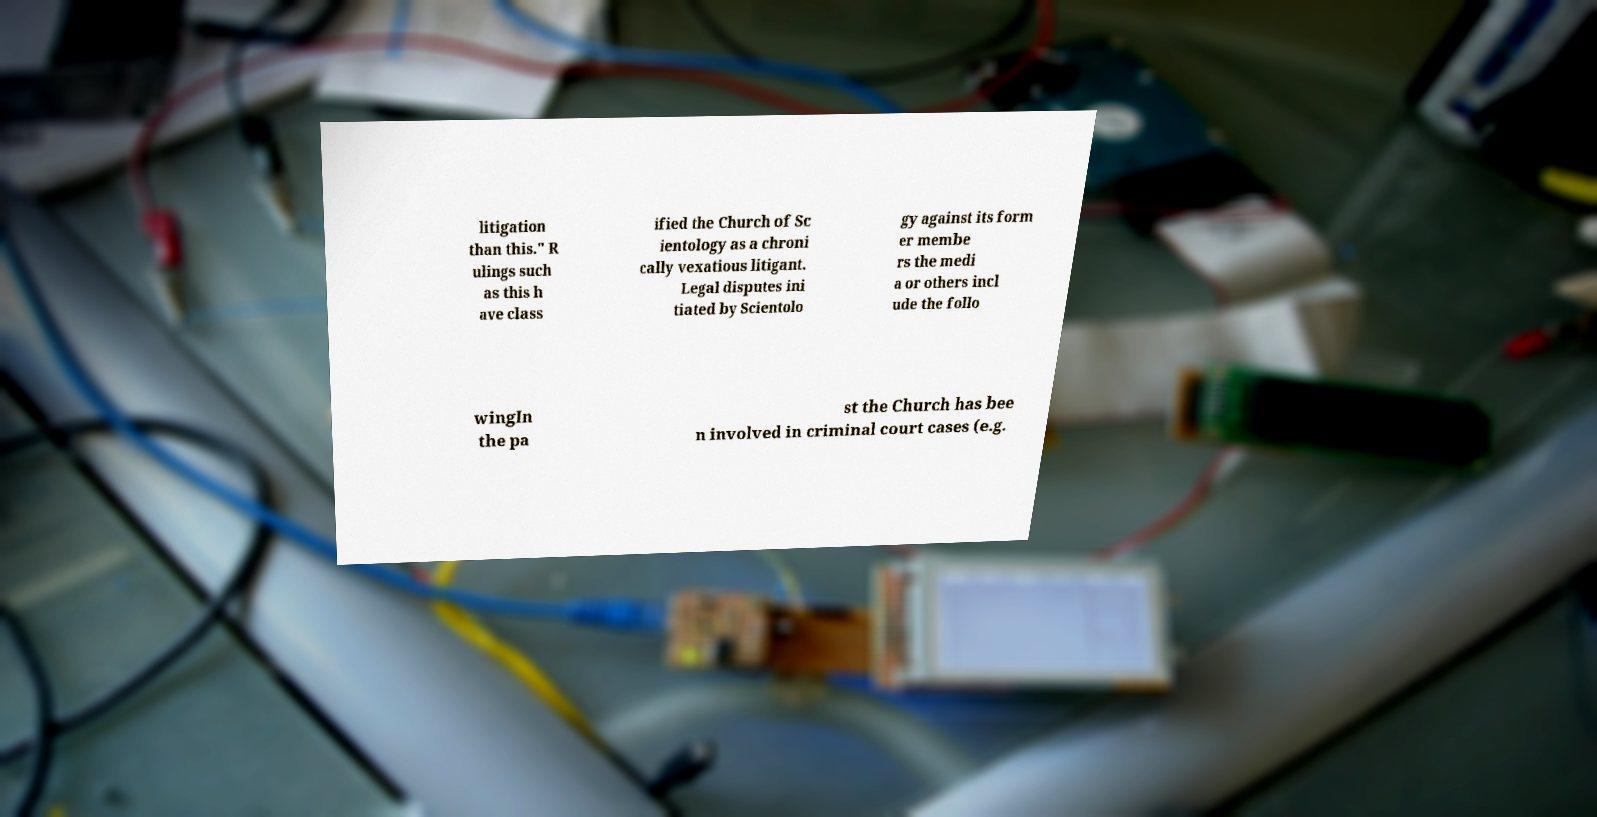I need the written content from this picture converted into text. Can you do that? litigation than this." R ulings such as this h ave class ified the Church of Sc ientology as a chroni cally vexatious litigant. Legal disputes ini tiated by Scientolo gy against its form er membe rs the medi a or others incl ude the follo wingIn the pa st the Church has bee n involved in criminal court cases (e.g. 